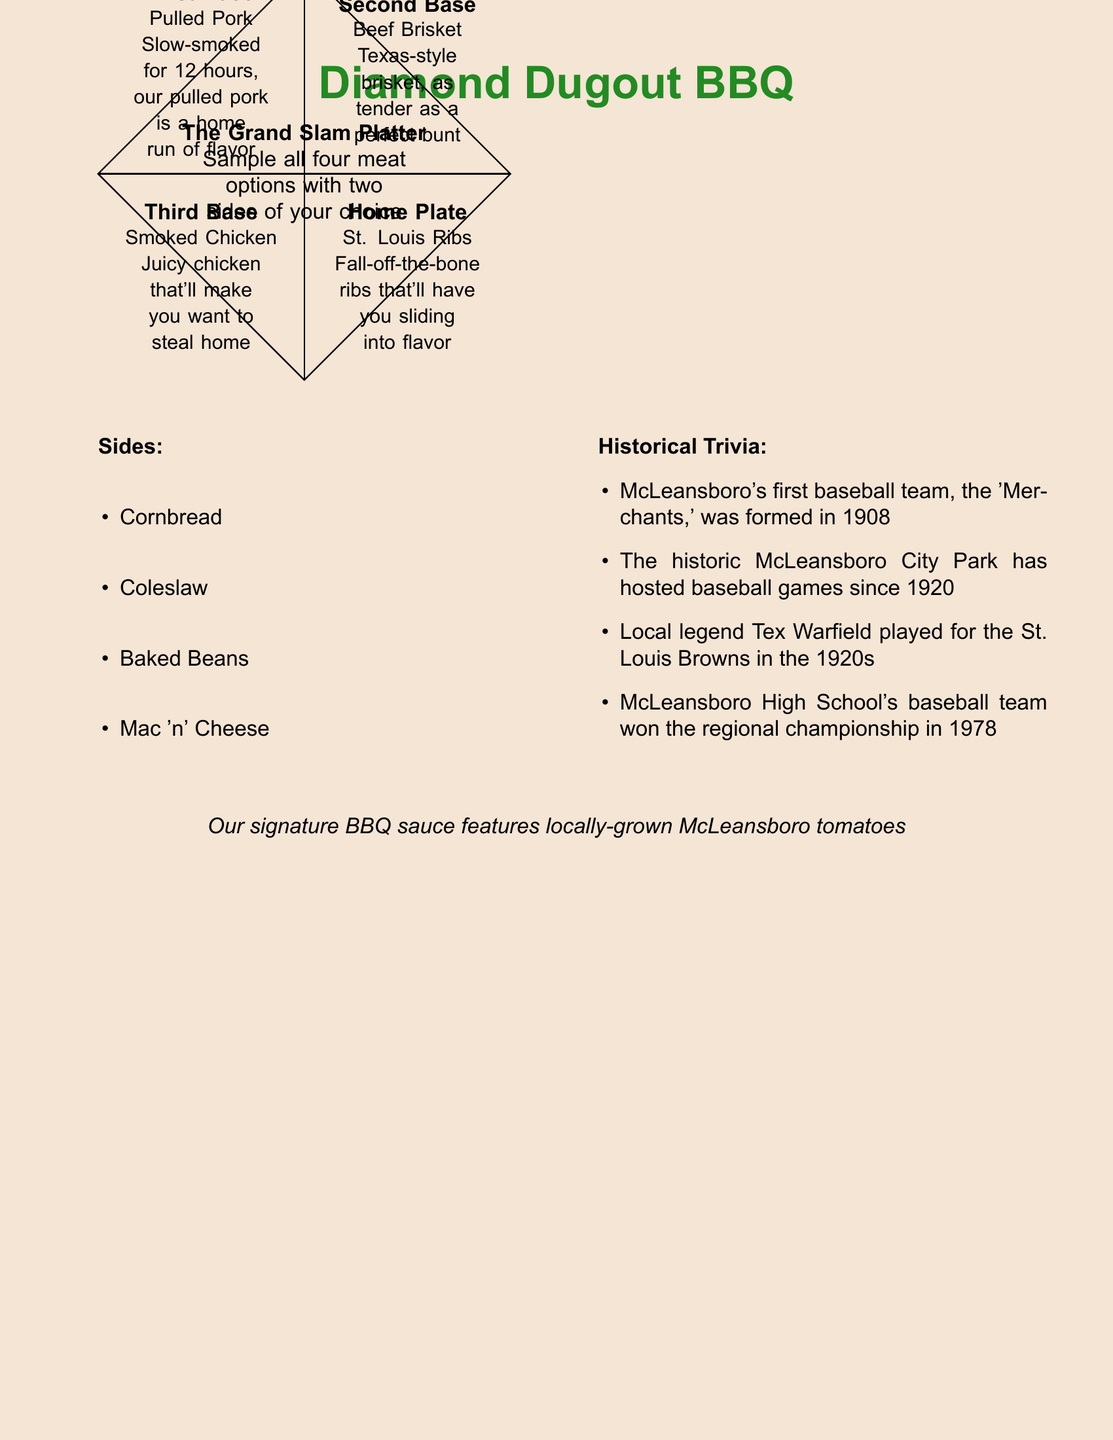what type of restaurant is Diamond Dugout BBQ? The restaurant menu indicates it is a barbecue restaurant.
Answer: barbecue how long is the pulled pork slow-smoked? The document states that the pulled pork is slow-smoked for 12 hours.
Answer: 12 hours what is served at home plate on the menu? The menu specifies that home plate features St. Louis Ribs.
Answer: St. Louis Ribs which year was the first baseball team in McLeansboro formed? The historical trivia mentions that the 'Merchants' baseball team was formed in 1908.
Answer: 1908 what meat option is at second base? The menu indicates that second base has beef brisket.
Answer: beef brisket how many sides can you choose with The Grand Slam Platter? The menu states that you can choose two sides with The Grand Slam Platter.
Answer: two sides who played for the St. Louis Browns in the 1920s? The document mentions that local legend Tex Warfield played for the St. Louis Browns.
Answer: Tex Warfield which side option is a dairy product? The menu lists mac 'n' cheese as a side option.
Answer: Mac 'n' Cheese what signature ingredient is used in the BBQ sauce? The document indicates that the signature BBQ sauce features locally-grown McLeansboro tomatoes.
Answer: McLeansboro tomatoes 